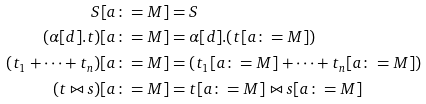Convert formula to latex. <formula><loc_0><loc_0><loc_500><loc_500>S [ a \colon = M ] & = S \\ ( \alpha [ d ] . t ) [ a \colon = M ] & = \alpha [ d ] . ( t [ a \colon = M ] ) \\ ( t _ { 1 } + \dots + t _ { n } ) [ a \colon = M ] & = ( t _ { 1 } [ a \colon = M ] + \dots + t _ { n } [ a \colon = M ] ) \\ ( t \bowtie s ) [ a \colon = M ] & = t [ a \colon = M ] \bowtie s [ a \colon = M ] \\</formula> 